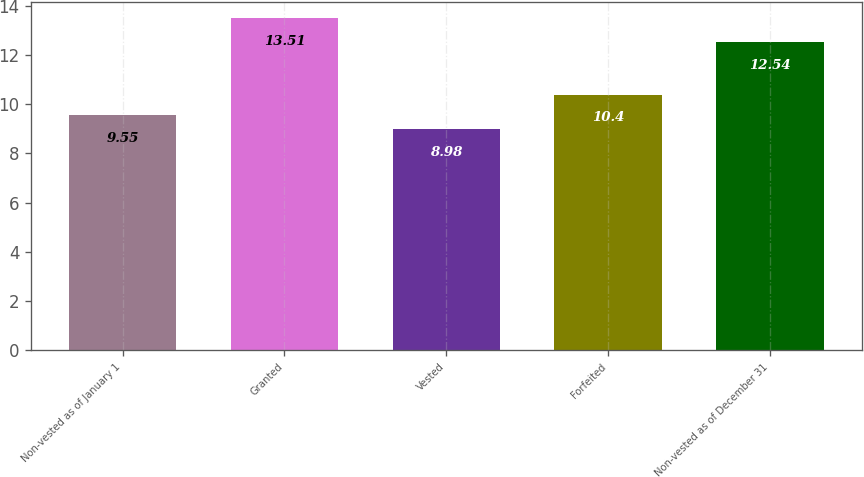Convert chart. <chart><loc_0><loc_0><loc_500><loc_500><bar_chart><fcel>Non-vested as of January 1<fcel>Granted<fcel>Vested<fcel>Forfeited<fcel>Non-vested as of December 31<nl><fcel>9.55<fcel>13.51<fcel>8.98<fcel>10.4<fcel>12.54<nl></chart> 